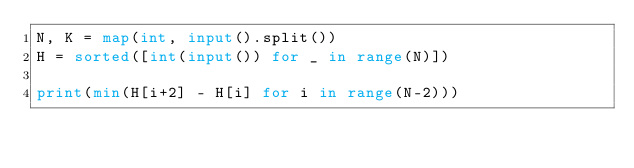Convert code to text. <code><loc_0><loc_0><loc_500><loc_500><_Python_>N, K = map(int, input().split())
H = sorted([int(input()) for _ in range(N)])

print(min(H[i+2] - H[i] for i in range(N-2)))
</code> 